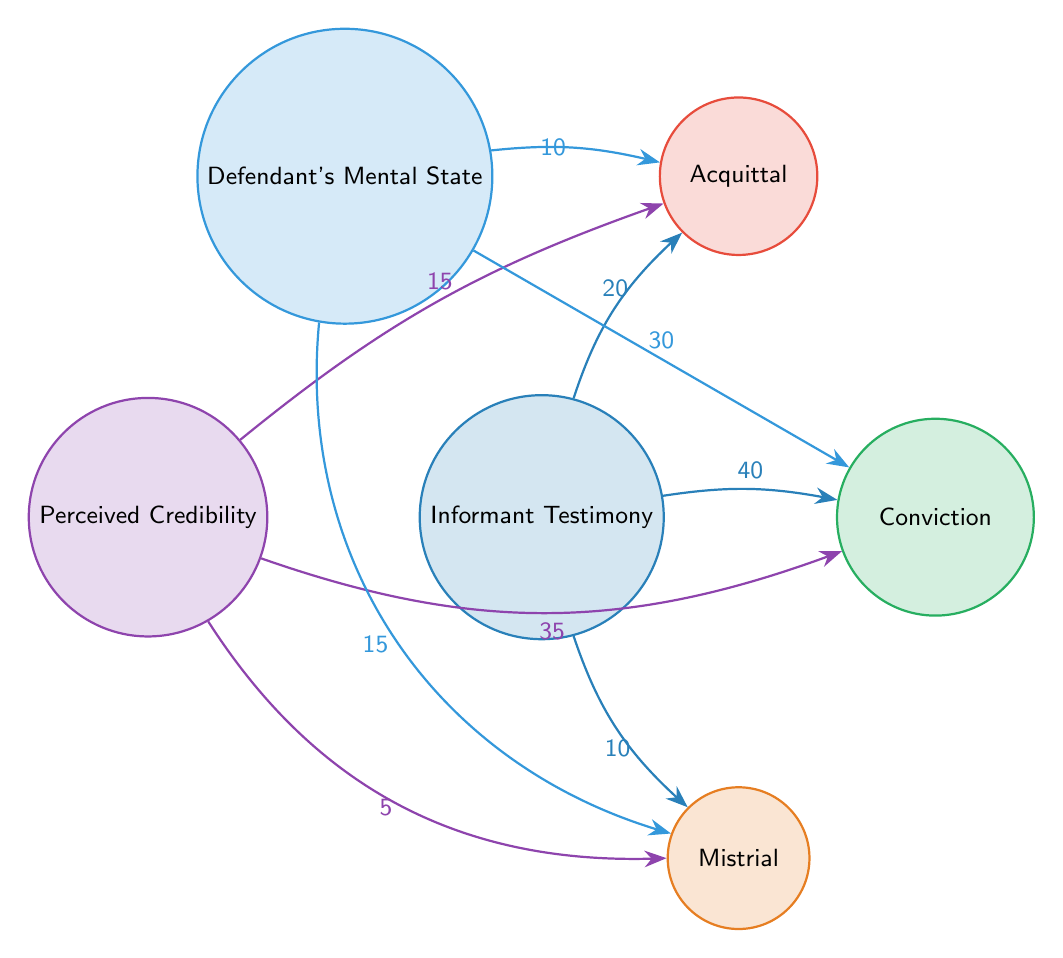What is the total number of nodes in the diagram? The nodes listed in the diagram include Informant Testimony, Acquittal, Conviction, Mistrial, Perceived Credibility, and Defendant's Mental State. Counting these, we find there are 6 nodes in total.
Answer: 6 What is the value representing the connection between Informant Testimony and Acquittal? The link from Informant Testimony to Acquittal has a value of 20, as indicated by the number above the arrow in the diagram.
Answer: 20 What is the value representing the connection from Perceived Credibility to Conviction? The arrow from Perceived Credibility to Conviction shows a value of 35, which is labeled along the link in the diagram.
Answer: 35 Which outcome is most affected by Informant Testimony according to the diagram? The diagram shows that Informant Testimony has the highest value connection to Conviction (40), indicating this outcome is most influenced by it.
Answer: Conviction What is the total value of connections leading to Mistrial? The values contributing to Mistrial come from Informant Testimony (10), Perceived Credibility (5), and Defendant's Mental State (15). Adding these values: 10 + 5 + 15 = 30, thus the total is 30.
Answer: 30 How does the Defendant's Mental State affect Conviction? The Defendant's Mental State has a direct link to Conviction with a value of 30, indicating a significant influence on this verdict.
Answer: 30 What is the least influential link connected to Mistrial? The connection from Perceived Credibility to Mistrial has the least influence with a value of 5, which is the smallest number linked to Mistrial in the diagram.
Answer: 5 Which node has the highest cumulative impact on Conviction? Both Informant Testimony (40) and Perceived Credibility (35) influence Conviction. The highest cumulative impact comes from Informant Testimony alone, which is 40.
Answer: Informant Testimony What does the link from Informant Testimony to Mistrial indicate? The diagram specifies that Informant Testimony contributes a value of 10 to Mistrial, showing it has some influence on this outcome but is relatively low compared to Conviction and Acquittal.
Answer: 10 